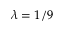<formula> <loc_0><loc_0><loc_500><loc_500>\lambda = 1 / 9</formula> 